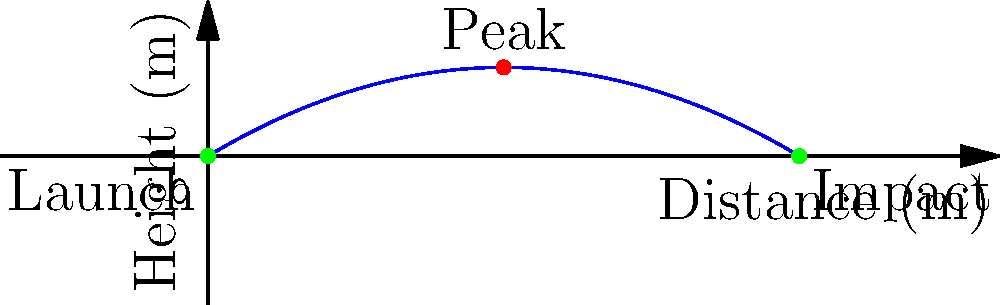A medieval trebuchet launches a projectile, and its trajectory can be modeled by the parabolic equation $h(x) = -0.02x^2 + 0.6x$, where $h$ is the height in meters and $x$ is the horizontal distance in meters. What is the maximum height reached by the projectile, and how far does it travel horizontally before hitting the ground? How might understanding this trajectory help in planning a siege during a historical reenactment? To solve this problem, we'll follow these steps:

1. Find the maximum height:
   a. The vertex of the parabola represents the maximum height.
   b. For a quadratic equation in the form $ax^2 + bx + c$, the x-coordinate of the vertex is given by $x = -\frac{b}{2a}$.
   c. In our equation, $a = -0.02$ and $b = 0.6$.
   d. $x = -\frac{0.6}{2(-0.02)} = 15$ meters

2. Calculate the maximum height:
   $h(15) = -0.02(15)^2 + 0.6(15) = -4.5 + 9 = 4.5$ meters

3. Find the horizontal distance traveled:
   a. At the impact point, $h(x) = 0$.
   b. Solve the equation: $0 = -0.02x^2 + 0.6x$
   c. Factor out $x$: $x(-0.02x + 0.6) = 0$
   d. Solutions: $x = 0$ (launch point) or $x = 30$ (impact point)

4. Historical reenactment application:
   Understanding the trajectory helps in:
   a. Positioning the trebuchet for accurate targeting.
   b. Determining safe zones for spectators.
   c. Recreating authentic siege strategies.
   d. Demonstrating the mathematical knowledge of medieval engineers.
Answer: Maximum height: 4.5 m; Horizontal distance: 30 m 